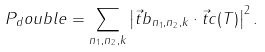Convert formula to latex. <formula><loc_0><loc_0><loc_500><loc_500>P _ { d } o u b l e = \sum _ { n _ { 1 } , n _ { 2 } , k } \left | \vec { t } { b } _ { n _ { 1 } , n _ { 2 } , k } \cdot \vec { t } { c } ( T ) \right | ^ { 2 } .</formula> 